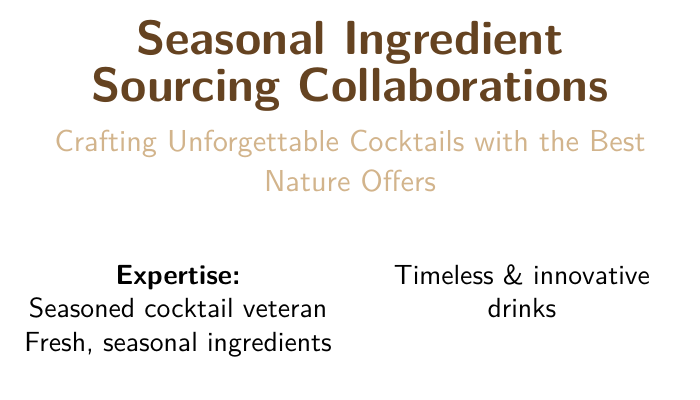What is the main focus of the business card? The business card emphasizes collaborations for obtaining seasonal ingredients to enhance cocktail crafting.
Answer: Seasonal Ingredient Sourcing Collaborations Who is the target audience of this business card? The target audience includes individuals and businesses interested in cocktail crafting with seasonal ingredients.
Answer: Cocktail industry professionals What is the expertise of the individual listed on the card? The expertise highlights experience in the cocktail industry, focusing on fresh ingredients and innovative drinks.
Answer: Seasoned cocktail veteran What ingredients sources are mentioned as key collaborations? The document lists specific farms and cooperatives for sourcing ingredients.
Answer: Smith's Organic Farms, Ocean Spray Cooperative, Mountain Blossom Honey What type of drinks is mentioned on the card? The card asserts that seasonal ingredients are used to create both innovative and classic cocktails.
Answer: Timeless & innovative drinks What color theme is used on the business card? The color theme features dark brown and light brown tones, which convey a natural and rustic feel.
Answer: Dark brown and light brown What is the style of the card's text? The document employs a sans-serif font style designed for readability and a sleek look.
Answer: Helvetica What kind of content is typical for a business card? Business cards typically include the individual's name, contact details, and areas of expertise related to their profession.
Answer: Contact information and expertise What is the size of the business card? The card is formatted to fit a standard business card size with slight margin adjustments.
Answer: 3.5 inches by 2 inches 